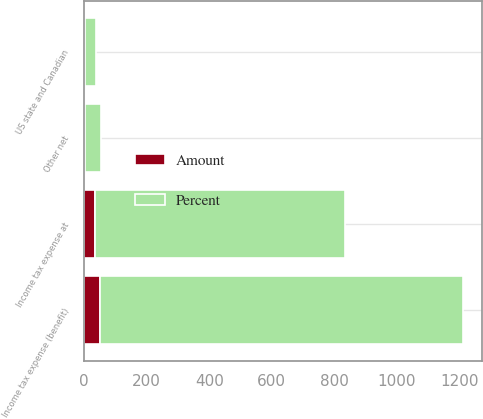Convert chart to OTSL. <chart><loc_0><loc_0><loc_500><loc_500><stacked_bar_chart><ecel><fcel>Income tax expense at<fcel>US state and Canadian<fcel>Other net<fcel>Income tax expense (benefit)<nl><fcel>Percent<fcel>799<fcel>37<fcel>52<fcel>1160<nl><fcel>Amount<fcel>35<fcel>1.6<fcel>2.3<fcel>50.9<nl></chart> 